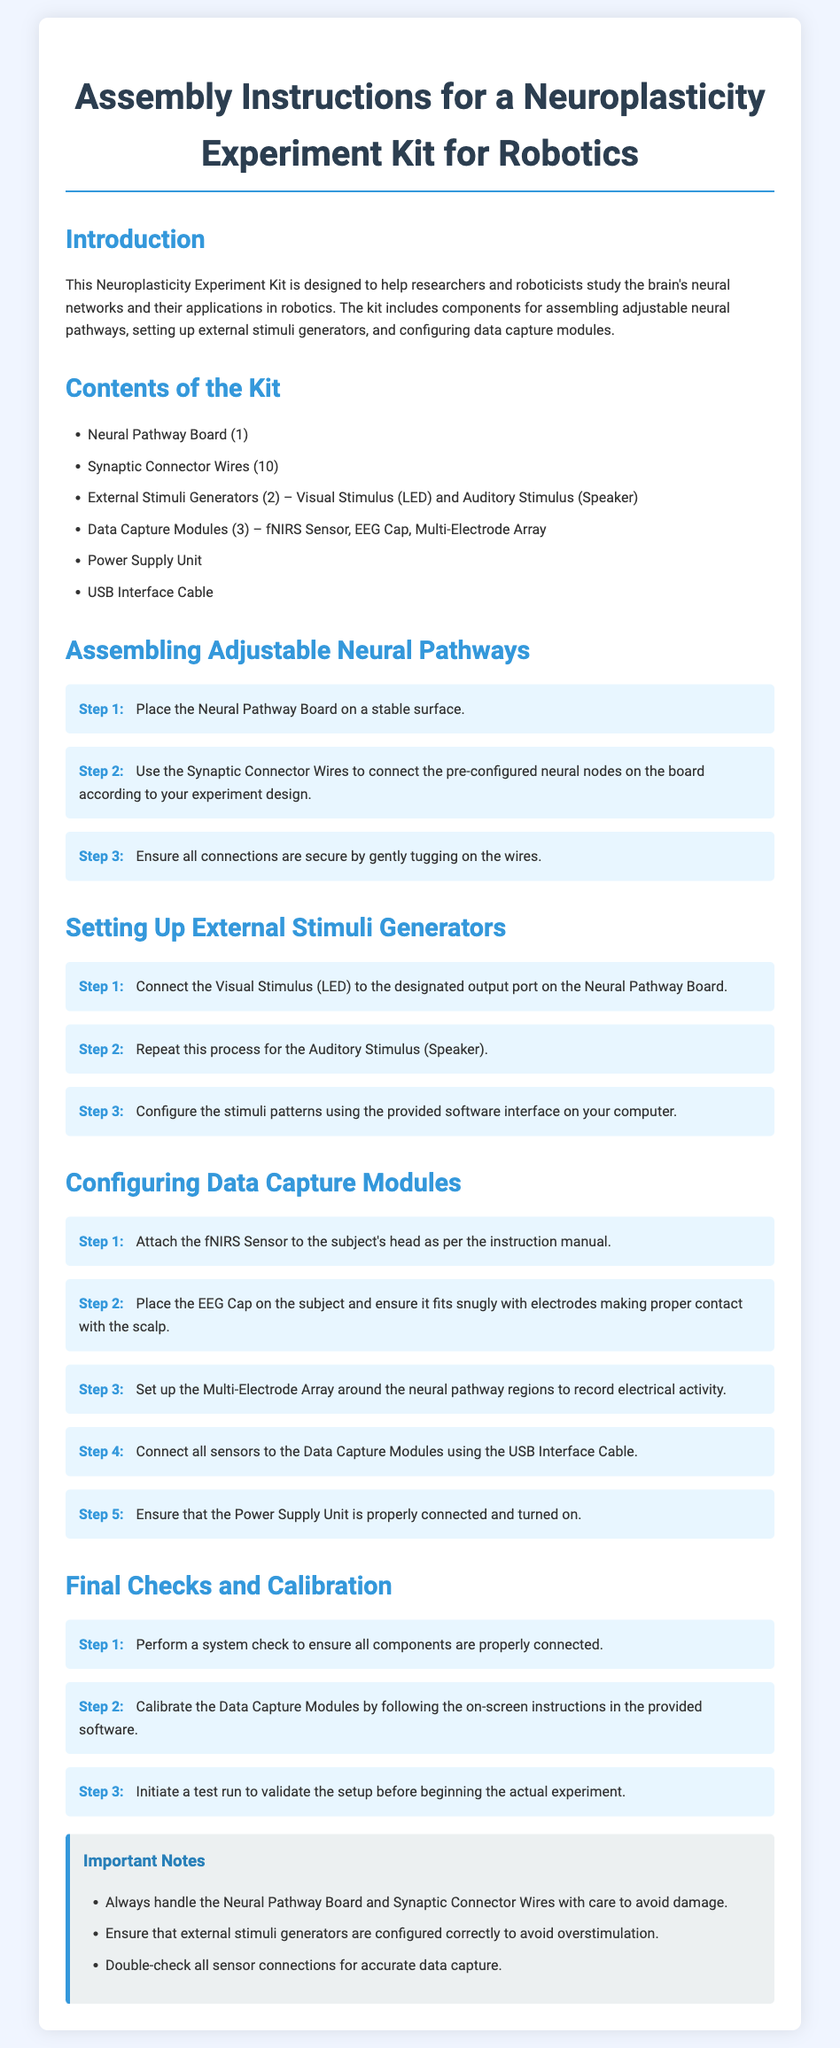What is the total number of external stimuli generators included in the kit? The document states there are 2 external stimuli generators mentioned in the kit contents.
Answer: 2 What is used to assemble adjustable neural pathways? The assembly instructions specifically mention using Synaptic Connector Wires to connect the neural nodes.
Answer: Synaptic Connector Wires How many Data Capture Modules are provided in the kit? The kit includes 3 Data Capture Modules as listed in the contents section.
Answer: 3 What component is used to provide visual stimuli? According to the document, the Visual Stimulus is provided by LED, which is part of the external stimuli generators.
Answer: LED What step involves connecting all sensors to the Data Capture Modules? Step 4 in the Configuring Data Capture Modules section details the action of connecting sensors using the USB Interface Cable.
Answer: Step 4 What should be done after all components are connected? The final checks require performing a system check ensures that all components are connected properly after assembly.
Answer: System check What is the first step in assembling the Neural Pathway Board? The first step in the assembly section requires placing the Neural Pathway Board on a stable surface.
Answer: Place on a stable surface How many synaptic connector wires are included in the kit? The document states that the kit includes 10 Synaptic Connector Wires.
Answer: 10 What component is required for auditory stimulation? The instructions specify that the Auditory Stimulus is provided by a Speaker.
Answer: Speaker 